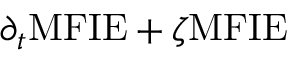<formula> <loc_0><loc_0><loc_500><loc_500>\partial _ { t } M F I E + \zeta M F I E</formula> 